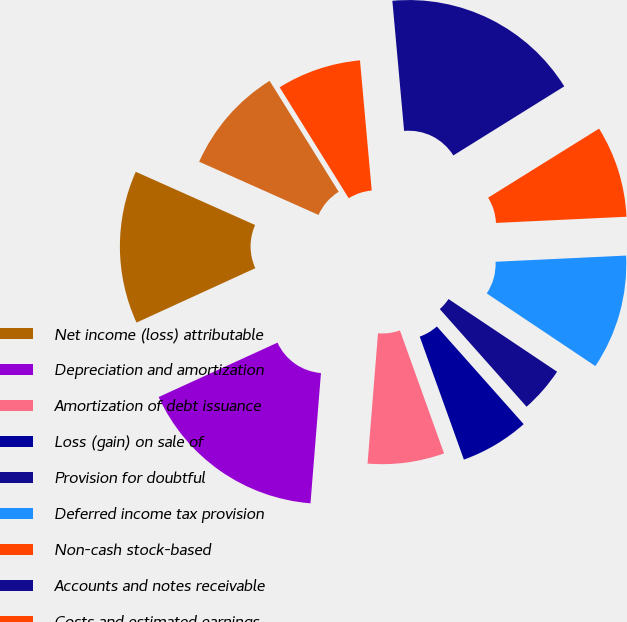Convert chart to OTSL. <chart><loc_0><loc_0><loc_500><loc_500><pie_chart><fcel>Net income (loss) attributable<fcel>Depreciation and amortization<fcel>Amortization of debt issuance<fcel>Loss (gain) on sale of<fcel>Provision for doubtful<fcel>Deferred income tax provision<fcel>Non-cash stock-based<fcel>Accounts and notes receivable<fcel>Costs and estimated earnings<fcel>Inventories<nl><fcel>13.51%<fcel>16.89%<fcel>6.76%<fcel>6.08%<fcel>4.05%<fcel>10.14%<fcel>8.11%<fcel>17.57%<fcel>7.43%<fcel>9.46%<nl></chart> 